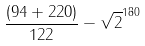<formula> <loc_0><loc_0><loc_500><loc_500>\frac { ( 9 4 + 2 2 0 ) } { 1 2 2 } - \sqrt { 2 } ^ { 1 8 0 }</formula> 